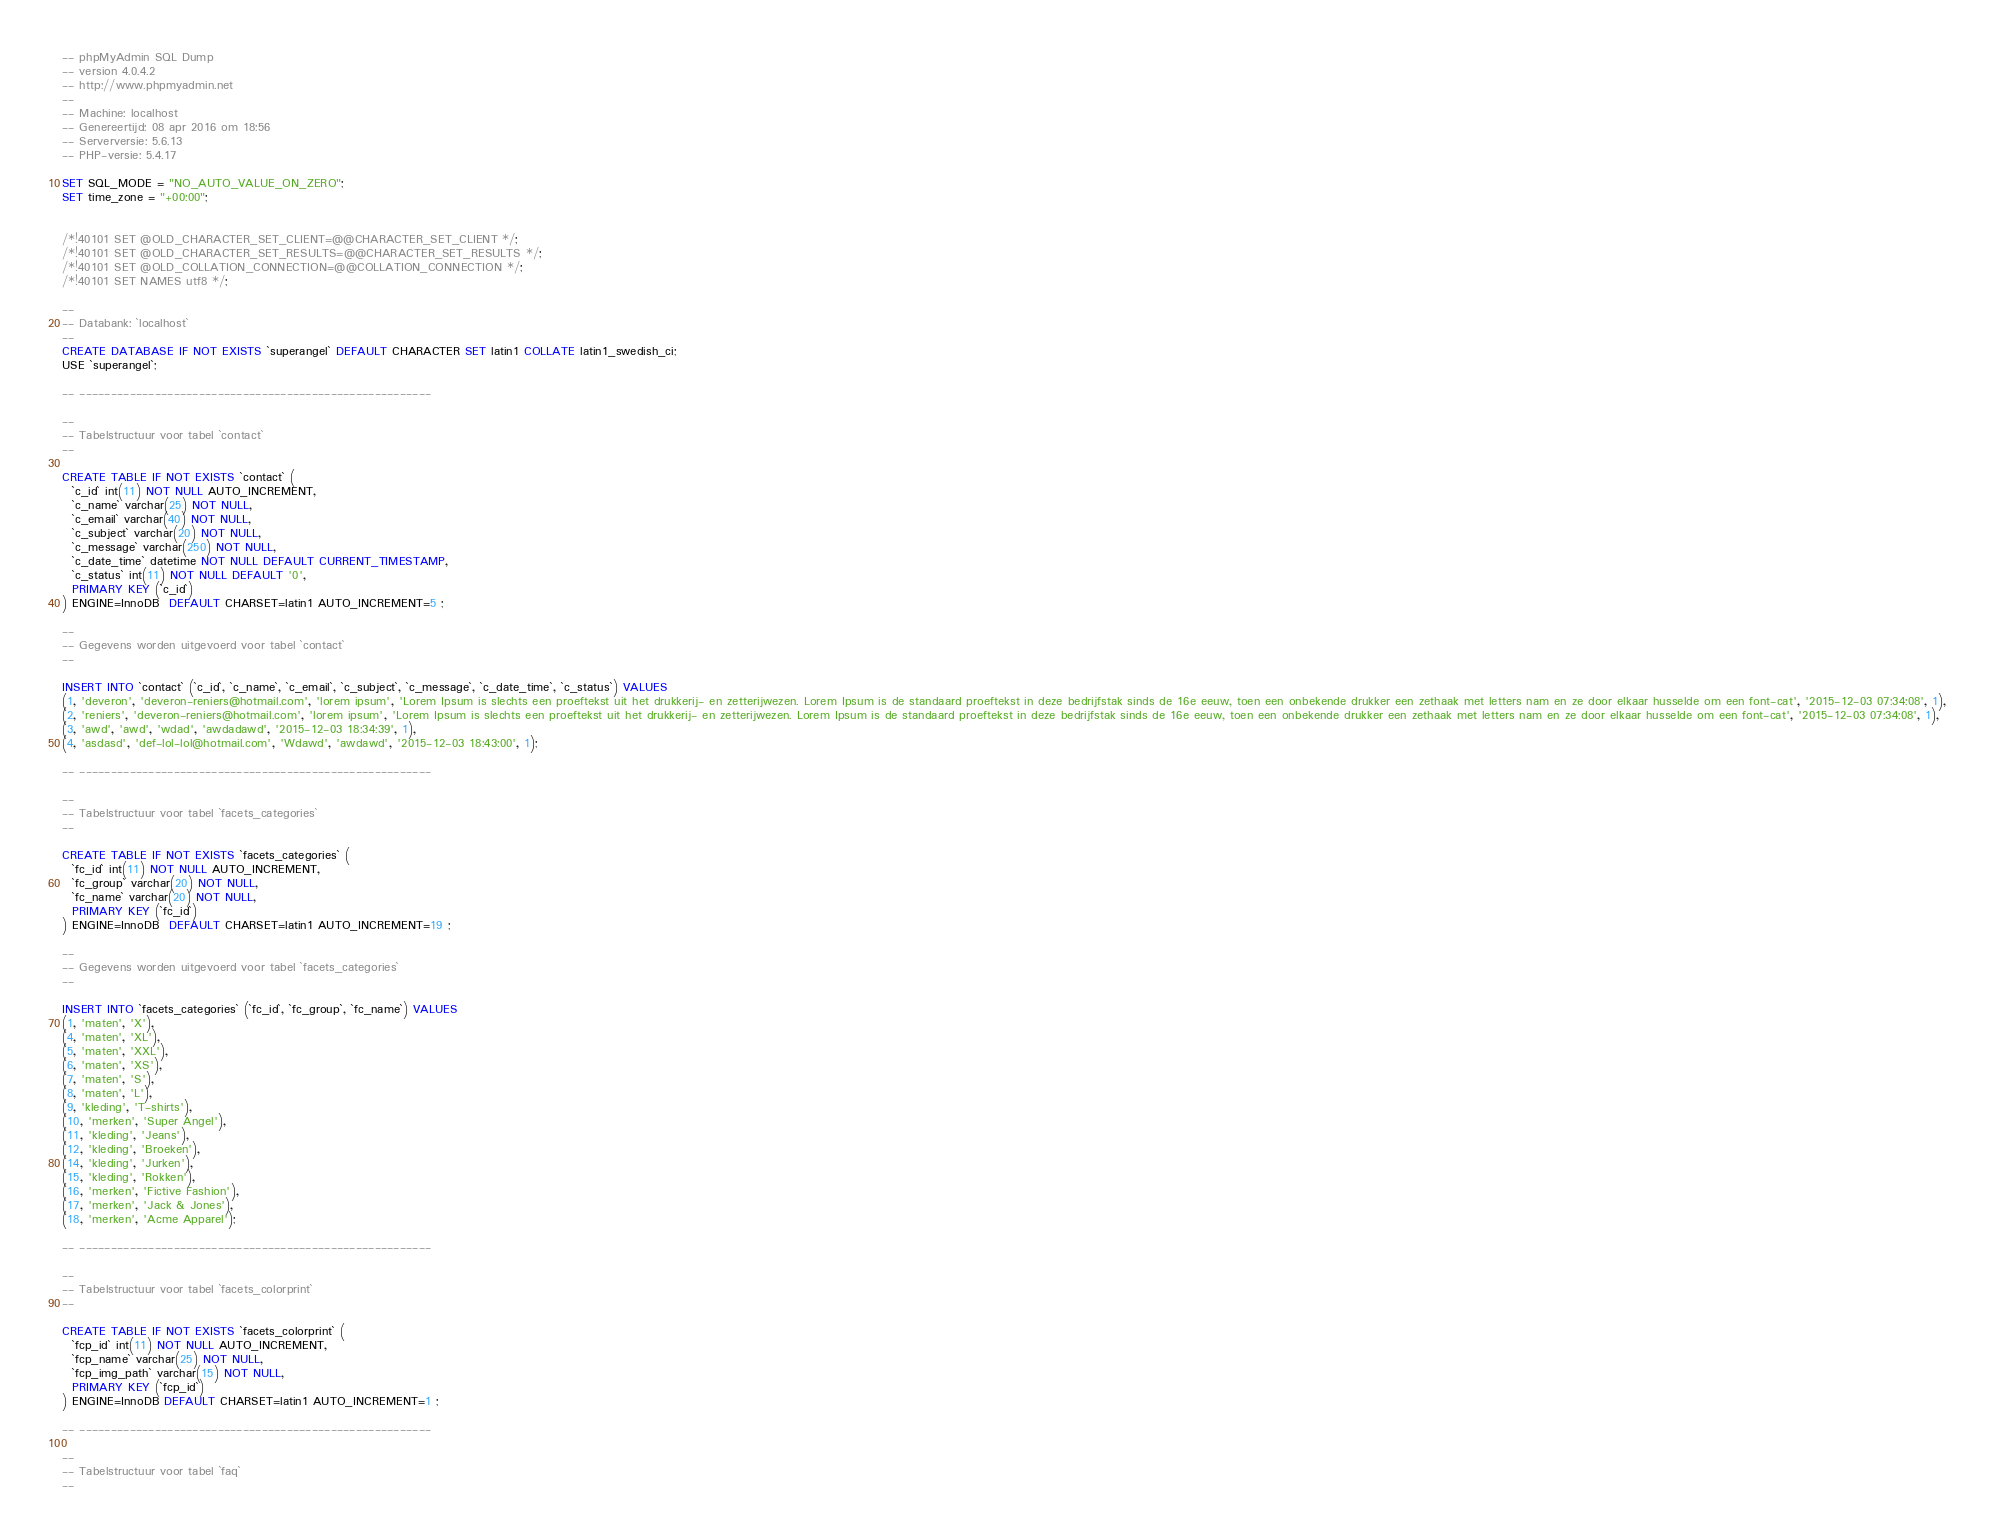Convert code to text. <code><loc_0><loc_0><loc_500><loc_500><_SQL_>-- phpMyAdmin SQL Dump
-- version 4.0.4.2
-- http://www.phpmyadmin.net
--
-- Machine: localhost
-- Genereertijd: 08 apr 2016 om 18:56
-- Serverversie: 5.6.13
-- PHP-versie: 5.4.17

SET SQL_MODE = "NO_AUTO_VALUE_ON_ZERO";
SET time_zone = "+00:00";


/*!40101 SET @OLD_CHARACTER_SET_CLIENT=@@CHARACTER_SET_CLIENT */;
/*!40101 SET @OLD_CHARACTER_SET_RESULTS=@@CHARACTER_SET_RESULTS */;
/*!40101 SET @OLD_COLLATION_CONNECTION=@@COLLATION_CONNECTION */;
/*!40101 SET NAMES utf8 */;

--
-- Databank: `localhost`
--
CREATE DATABASE IF NOT EXISTS `superangel` DEFAULT CHARACTER SET latin1 COLLATE latin1_swedish_ci;
USE `superangel`;

-- --------------------------------------------------------

--
-- Tabelstructuur voor tabel `contact`
--

CREATE TABLE IF NOT EXISTS `contact` (
  `c_id` int(11) NOT NULL AUTO_INCREMENT,
  `c_name` varchar(25) NOT NULL,
  `c_email` varchar(40) NOT NULL,
  `c_subject` varchar(20) NOT NULL,
  `c_message` varchar(250) NOT NULL,
  `c_date_time` datetime NOT NULL DEFAULT CURRENT_TIMESTAMP,
  `c_status` int(11) NOT NULL DEFAULT '0',
  PRIMARY KEY (`c_id`)
) ENGINE=InnoDB  DEFAULT CHARSET=latin1 AUTO_INCREMENT=5 ;

--
-- Gegevens worden uitgevoerd voor tabel `contact`
--

INSERT INTO `contact` (`c_id`, `c_name`, `c_email`, `c_subject`, `c_message`, `c_date_time`, `c_status`) VALUES
(1, 'deveron', 'deveron-reniers@hotmail.com', 'lorem ipsum', 'Lorem Ipsum is slechts een proeftekst uit het drukkerij- en zetterijwezen. Lorem Ipsum is de standaard proeftekst in deze bedrijfstak sinds de 16e eeuw, toen een onbekende drukker een zethaak met letters nam en ze door elkaar husselde om een font-cat', '2015-12-03 07:34:08', 1),
(2, 'reniers', 'deveron-reniers@hotmail.com', 'lorem ipsum', 'Lorem Ipsum is slechts een proeftekst uit het drukkerij- en zetterijwezen. Lorem Ipsum is de standaard proeftekst in deze bedrijfstak sinds de 16e eeuw, toen een onbekende drukker een zethaak met letters nam en ze door elkaar husselde om een font-cat', '2015-12-03 07:34:08', 1),
(3, 'awd', 'awd', 'wdad', 'awdadawd', '2015-12-03 18:34:39', 1),
(4, 'asdasd', 'def-lol-lol@hotmail.com', 'Wdawd', 'awdawd', '2015-12-03 18:43:00', 1);

-- --------------------------------------------------------

--
-- Tabelstructuur voor tabel `facets_categories`
--

CREATE TABLE IF NOT EXISTS `facets_categories` (
  `fc_id` int(11) NOT NULL AUTO_INCREMENT,
  `fc_group` varchar(20) NOT NULL,
  `fc_name` varchar(20) NOT NULL,
  PRIMARY KEY (`fc_id`)
) ENGINE=InnoDB  DEFAULT CHARSET=latin1 AUTO_INCREMENT=19 ;

--
-- Gegevens worden uitgevoerd voor tabel `facets_categories`
--

INSERT INTO `facets_categories` (`fc_id`, `fc_group`, `fc_name`) VALUES
(1, 'maten', 'X'),
(4, 'maten', 'XL'),
(5, 'maten', 'XXL'),
(6, 'maten', 'XS'),
(7, 'maten', 'S'),
(8, 'maten', 'L'),
(9, 'kleding', 'T-shirts'),
(10, 'merken', 'Super Angel'),
(11, 'kleding', 'Jeans'),
(12, 'kleding', 'Broeken'),
(14, 'kleding', 'Jurken'),
(15, 'kleding', 'Rokken'),
(16, 'merken', 'Fictive Fashion'),
(17, 'merken', 'Jack & Jones'),
(18, 'merken', 'Acme Apparel');

-- --------------------------------------------------------

--
-- Tabelstructuur voor tabel `facets_colorprint`
--

CREATE TABLE IF NOT EXISTS `facets_colorprint` (
  `fcp_id` int(11) NOT NULL AUTO_INCREMENT,
  `fcp_name` varchar(25) NOT NULL,
  `fcp_img_path` varchar(15) NOT NULL,
  PRIMARY KEY (`fcp_id`)
) ENGINE=InnoDB DEFAULT CHARSET=latin1 AUTO_INCREMENT=1 ;

-- --------------------------------------------------------

--
-- Tabelstructuur voor tabel `faq`
--
</code> 